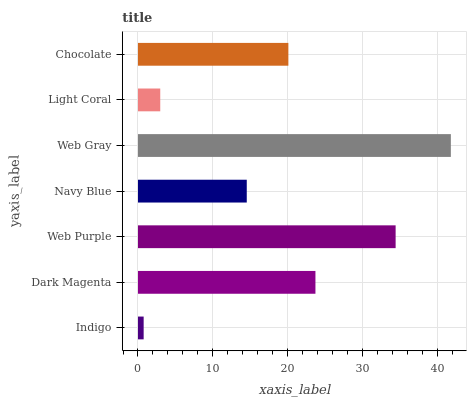Is Indigo the minimum?
Answer yes or no. Yes. Is Web Gray the maximum?
Answer yes or no. Yes. Is Dark Magenta the minimum?
Answer yes or no. No. Is Dark Magenta the maximum?
Answer yes or no. No. Is Dark Magenta greater than Indigo?
Answer yes or no. Yes. Is Indigo less than Dark Magenta?
Answer yes or no. Yes. Is Indigo greater than Dark Magenta?
Answer yes or no. No. Is Dark Magenta less than Indigo?
Answer yes or no. No. Is Chocolate the high median?
Answer yes or no. Yes. Is Chocolate the low median?
Answer yes or no. Yes. Is Web Gray the high median?
Answer yes or no. No. Is Web Gray the low median?
Answer yes or no. No. 